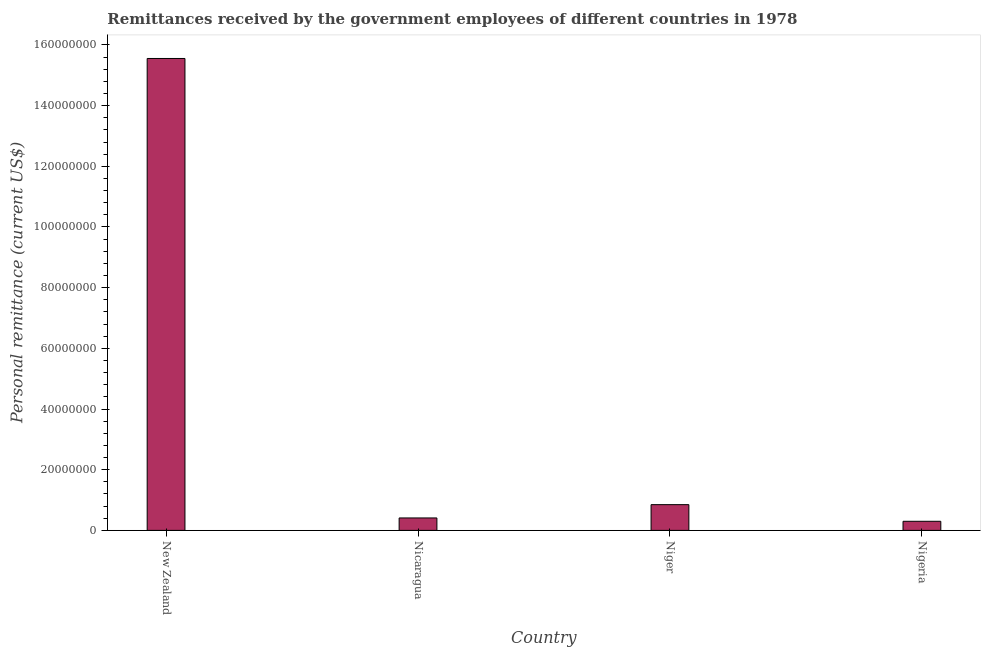Does the graph contain any zero values?
Give a very brief answer. No. What is the title of the graph?
Make the answer very short. Remittances received by the government employees of different countries in 1978. What is the label or title of the Y-axis?
Provide a succinct answer. Personal remittance (current US$). What is the personal remittances in Nigeria?
Your answer should be very brief. 3.00e+06. Across all countries, what is the maximum personal remittances?
Your response must be concise. 1.56e+08. Across all countries, what is the minimum personal remittances?
Keep it short and to the point. 3.00e+06. In which country was the personal remittances maximum?
Keep it short and to the point. New Zealand. In which country was the personal remittances minimum?
Ensure brevity in your answer.  Nigeria. What is the sum of the personal remittances?
Provide a short and direct response. 1.71e+08. What is the difference between the personal remittances in Nicaragua and Nigeria?
Your answer should be very brief. 1.10e+06. What is the average personal remittances per country?
Your answer should be compact. 4.28e+07. What is the median personal remittances?
Your answer should be compact. 6.29e+06. In how many countries, is the personal remittances greater than 136000000 US$?
Offer a very short reply. 1. What is the ratio of the personal remittances in New Zealand to that in Nigeria?
Ensure brevity in your answer.  51.84. What is the difference between the highest and the second highest personal remittances?
Provide a short and direct response. 1.47e+08. Is the sum of the personal remittances in New Zealand and Niger greater than the maximum personal remittances across all countries?
Ensure brevity in your answer.  Yes. What is the difference between the highest and the lowest personal remittances?
Offer a very short reply. 1.53e+08. Are all the bars in the graph horizontal?
Make the answer very short. No. What is the Personal remittance (current US$) of New Zealand?
Your response must be concise. 1.56e+08. What is the Personal remittance (current US$) of Nicaragua?
Offer a very short reply. 4.10e+06. What is the Personal remittance (current US$) of Niger?
Your answer should be very brief. 8.49e+06. What is the difference between the Personal remittance (current US$) in New Zealand and Nicaragua?
Provide a succinct answer. 1.51e+08. What is the difference between the Personal remittance (current US$) in New Zealand and Niger?
Your answer should be very brief. 1.47e+08. What is the difference between the Personal remittance (current US$) in New Zealand and Nigeria?
Provide a succinct answer. 1.53e+08. What is the difference between the Personal remittance (current US$) in Nicaragua and Niger?
Give a very brief answer. -4.39e+06. What is the difference between the Personal remittance (current US$) in Nicaragua and Nigeria?
Give a very brief answer. 1.10e+06. What is the difference between the Personal remittance (current US$) in Niger and Nigeria?
Your response must be concise. 5.49e+06. What is the ratio of the Personal remittance (current US$) in New Zealand to that in Nicaragua?
Provide a short and direct response. 37.94. What is the ratio of the Personal remittance (current US$) in New Zealand to that in Niger?
Provide a succinct answer. 18.33. What is the ratio of the Personal remittance (current US$) in New Zealand to that in Nigeria?
Your answer should be very brief. 51.84. What is the ratio of the Personal remittance (current US$) in Nicaragua to that in Niger?
Keep it short and to the point. 0.48. What is the ratio of the Personal remittance (current US$) in Nicaragua to that in Nigeria?
Your answer should be very brief. 1.37. What is the ratio of the Personal remittance (current US$) in Niger to that in Nigeria?
Provide a short and direct response. 2.83. 